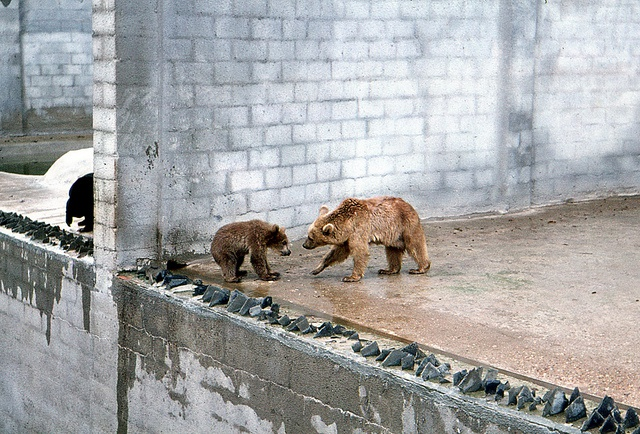Describe the objects in this image and their specific colors. I can see bear in gray, tan, black, and maroon tones, bear in gray, black, and maroon tones, and bear in gray, black, white, and navy tones in this image. 